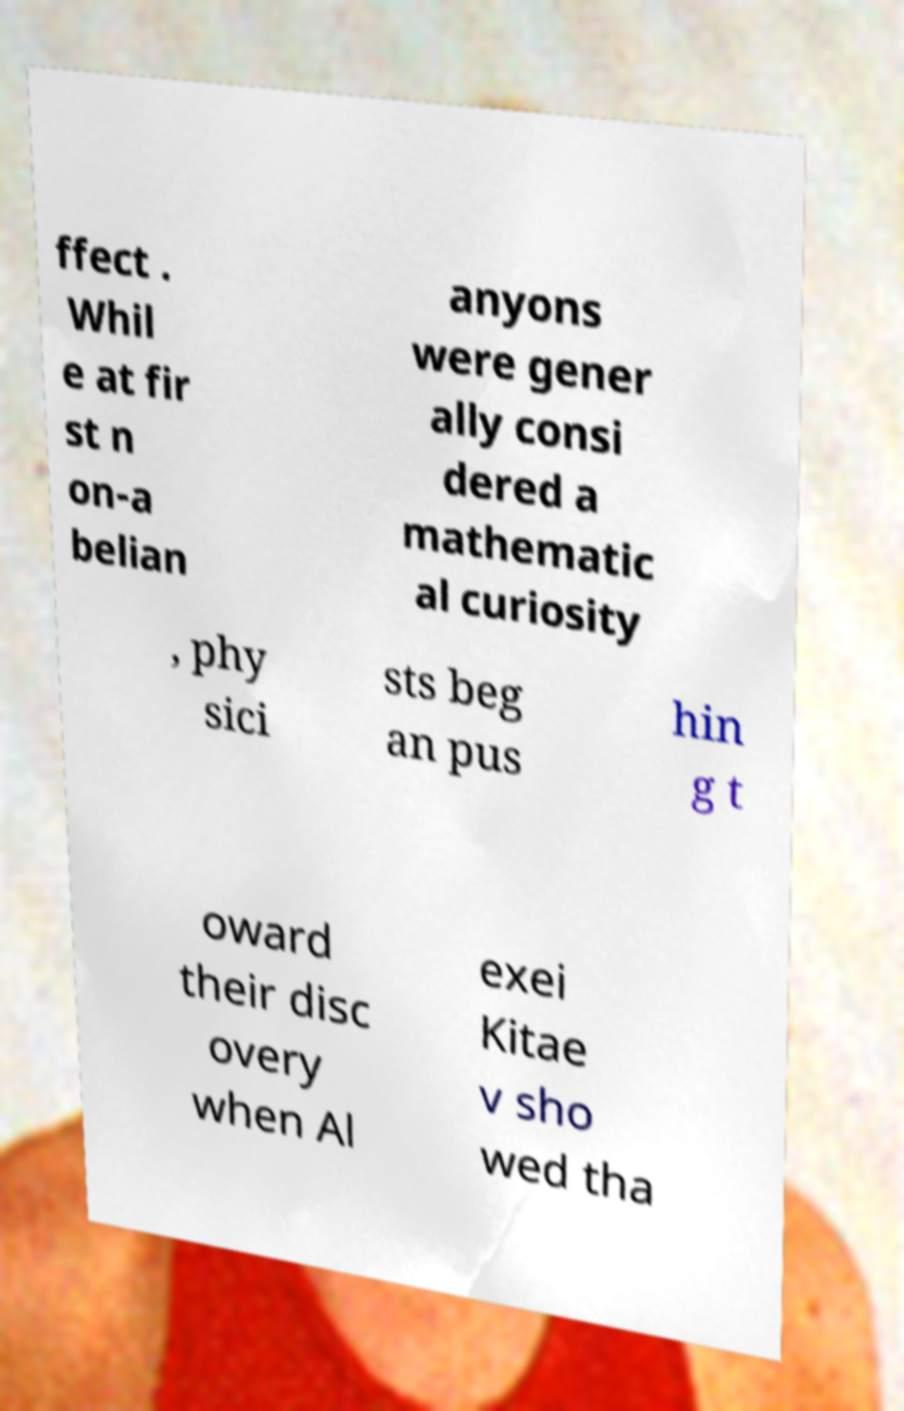What messages or text are displayed in this image? I need them in a readable, typed format. ffect . Whil e at fir st n on-a belian anyons were gener ally consi dered a mathematic al curiosity , phy sici sts beg an pus hin g t oward their disc overy when Al exei Kitae v sho wed tha 